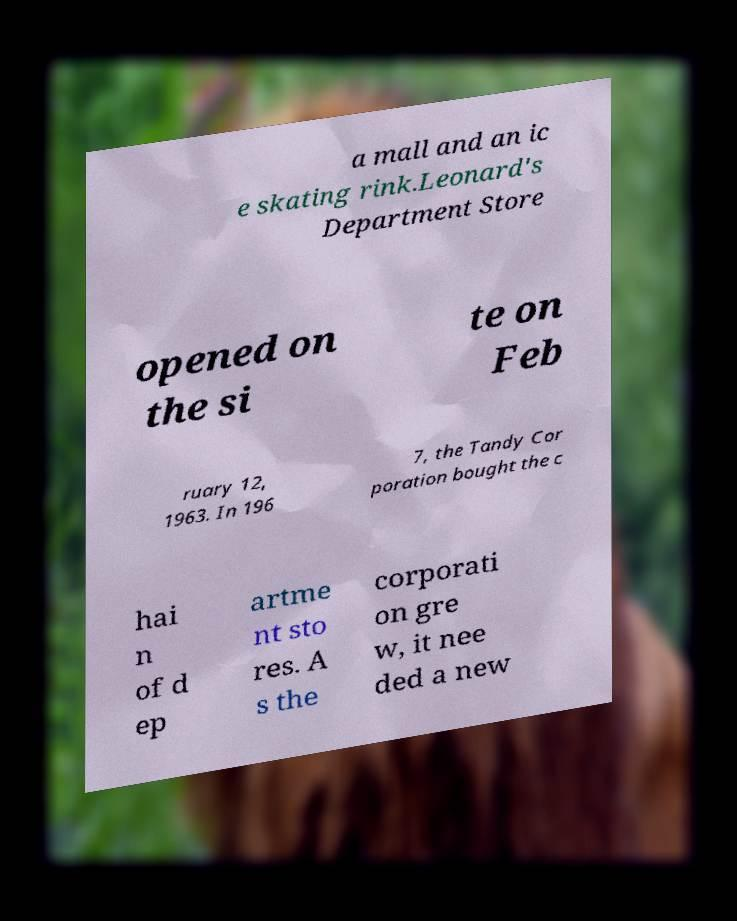I need the written content from this picture converted into text. Can you do that? a mall and an ic e skating rink.Leonard's Department Store opened on the si te on Feb ruary 12, 1963. In 196 7, the Tandy Cor poration bought the c hai n of d ep artme nt sto res. A s the corporati on gre w, it nee ded a new 